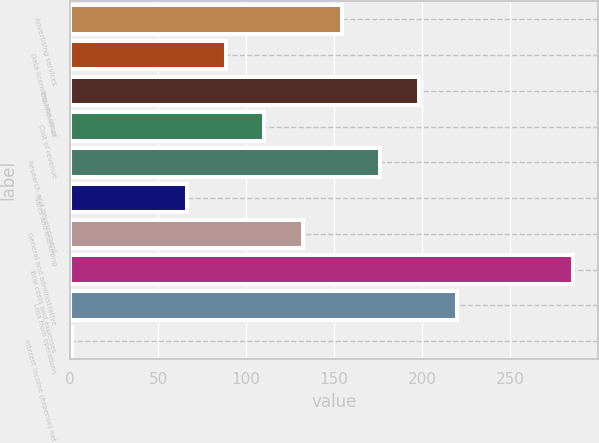Convert chart to OTSL. <chart><loc_0><loc_0><loc_500><loc_500><bar_chart><fcel>Advertising services<fcel>Data licensing and other<fcel>Total Revenue<fcel>Cost of revenue<fcel>Research and development<fcel>Sales and marketing<fcel>General and administrative<fcel>Total costs and expenses<fcel>Loss from operations<fcel>Interest income (expense) net<nl><fcel>154.3<fcel>88.6<fcel>198.1<fcel>110.5<fcel>176.2<fcel>66.7<fcel>132.4<fcel>285.7<fcel>220<fcel>1<nl></chart> 